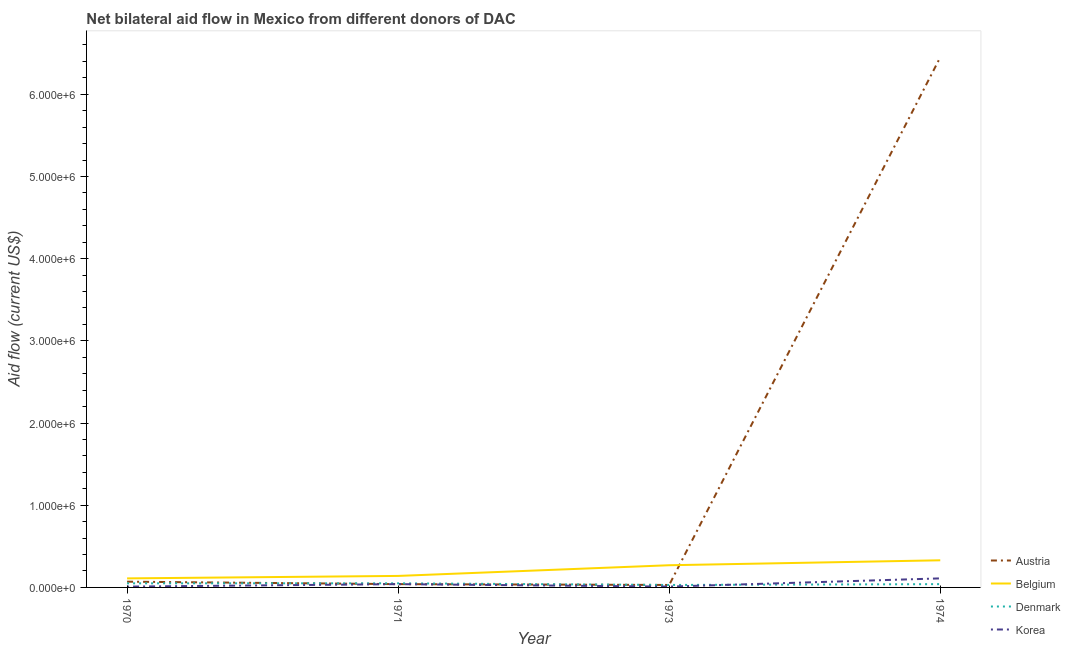How many different coloured lines are there?
Offer a terse response. 4. Is the number of lines equal to the number of legend labels?
Provide a short and direct response. Yes. What is the amount of aid given by korea in 1974?
Ensure brevity in your answer.  1.10e+05. Across all years, what is the maximum amount of aid given by austria?
Your response must be concise. 6.45e+06. Across all years, what is the minimum amount of aid given by belgium?
Your answer should be compact. 1.10e+05. What is the total amount of aid given by austria in the graph?
Your answer should be very brief. 6.59e+06. What is the difference between the amount of aid given by korea in 1971 and that in 1973?
Make the answer very short. 3.00e+04. What is the difference between the amount of aid given by belgium in 1971 and the amount of aid given by korea in 1973?
Your answer should be compact. 1.30e+05. What is the average amount of aid given by denmark per year?
Provide a succinct answer. 4.25e+04. In the year 1970, what is the difference between the amount of aid given by denmark and amount of aid given by belgium?
Your answer should be very brief. -6.00e+04. What is the ratio of the amount of aid given by austria in 1970 to that in 1974?
Ensure brevity in your answer.  0.01. Is the difference between the amount of aid given by austria in 1970 and 1974 greater than the difference between the amount of aid given by korea in 1970 and 1974?
Your answer should be very brief. No. What is the difference between the highest and the second highest amount of aid given by austria?
Keep it short and to the point. 6.38e+06. What is the difference between the highest and the lowest amount of aid given by denmark?
Give a very brief answer. 2.00e+04. Is the sum of the amount of aid given by belgium in 1970 and 1974 greater than the maximum amount of aid given by denmark across all years?
Offer a very short reply. Yes. Is it the case that in every year, the sum of the amount of aid given by austria and amount of aid given by belgium is greater than the amount of aid given by denmark?
Offer a very short reply. Yes. Does the amount of aid given by belgium monotonically increase over the years?
Make the answer very short. Yes. Is the amount of aid given by korea strictly greater than the amount of aid given by belgium over the years?
Offer a terse response. No. Is the amount of aid given by austria strictly less than the amount of aid given by denmark over the years?
Give a very brief answer. No. How many lines are there?
Provide a short and direct response. 4. How many years are there in the graph?
Ensure brevity in your answer.  4. Are the values on the major ticks of Y-axis written in scientific E-notation?
Ensure brevity in your answer.  Yes. Where does the legend appear in the graph?
Provide a short and direct response. Bottom right. How many legend labels are there?
Provide a succinct answer. 4. How are the legend labels stacked?
Offer a terse response. Vertical. What is the title of the graph?
Offer a very short reply. Net bilateral aid flow in Mexico from different donors of DAC. Does "Subsidies and Transfers" appear as one of the legend labels in the graph?
Offer a very short reply. No. What is the label or title of the X-axis?
Your answer should be very brief. Year. What is the label or title of the Y-axis?
Give a very brief answer. Aid flow (current US$). What is the Aid flow (current US$) of Denmark in 1970?
Your answer should be very brief. 5.00e+04. What is the Aid flow (current US$) of Austria in 1971?
Ensure brevity in your answer.  4.00e+04. What is the Aid flow (current US$) in Belgium in 1971?
Give a very brief answer. 1.40e+05. What is the Aid flow (current US$) of Denmark in 1971?
Make the answer very short. 5.00e+04. What is the Aid flow (current US$) of Austria in 1973?
Offer a terse response. 3.00e+04. What is the Aid flow (current US$) of Belgium in 1973?
Provide a short and direct response. 2.70e+05. What is the Aid flow (current US$) of Austria in 1974?
Offer a terse response. 6.45e+06. What is the Aid flow (current US$) of Korea in 1974?
Your answer should be very brief. 1.10e+05. Across all years, what is the maximum Aid flow (current US$) in Austria?
Give a very brief answer. 6.45e+06. Across all years, what is the maximum Aid flow (current US$) in Korea?
Offer a very short reply. 1.10e+05. Across all years, what is the minimum Aid flow (current US$) of Belgium?
Your answer should be compact. 1.10e+05. Across all years, what is the minimum Aid flow (current US$) in Denmark?
Your answer should be compact. 3.00e+04. Across all years, what is the minimum Aid flow (current US$) in Korea?
Your answer should be very brief. 10000. What is the total Aid flow (current US$) in Austria in the graph?
Your response must be concise. 6.59e+06. What is the total Aid flow (current US$) of Belgium in the graph?
Offer a very short reply. 8.50e+05. What is the total Aid flow (current US$) in Denmark in the graph?
Keep it short and to the point. 1.70e+05. What is the total Aid flow (current US$) of Korea in the graph?
Your answer should be very brief. 1.70e+05. What is the difference between the Aid flow (current US$) of Austria in 1970 and that in 1971?
Your response must be concise. 3.00e+04. What is the difference between the Aid flow (current US$) of Belgium in 1970 and that in 1971?
Give a very brief answer. -3.00e+04. What is the difference between the Aid flow (current US$) in Denmark in 1970 and that in 1971?
Provide a succinct answer. 0. What is the difference between the Aid flow (current US$) in Austria in 1970 and that in 1973?
Make the answer very short. 4.00e+04. What is the difference between the Aid flow (current US$) of Denmark in 1970 and that in 1973?
Provide a succinct answer. 2.00e+04. What is the difference between the Aid flow (current US$) in Austria in 1970 and that in 1974?
Give a very brief answer. -6.38e+06. What is the difference between the Aid flow (current US$) of Denmark in 1970 and that in 1974?
Your response must be concise. 10000. What is the difference between the Aid flow (current US$) of Korea in 1970 and that in 1974?
Provide a succinct answer. -1.00e+05. What is the difference between the Aid flow (current US$) in Denmark in 1971 and that in 1973?
Your answer should be compact. 2.00e+04. What is the difference between the Aid flow (current US$) in Austria in 1971 and that in 1974?
Keep it short and to the point. -6.41e+06. What is the difference between the Aid flow (current US$) of Denmark in 1971 and that in 1974?
Ensure brevity in your answer.  10000. What is the difference between the Aid flow (current US$) in Korea in 1971 and that in 1974?
Your response must be concise. -7.00e+04. What is the difference between the Aid flow (current US$) of Austria in 1973 and that in 1974?
Make the answer very short. -6.42e+06. What is the difference between the Aid flow (current US$) of Denmark in 1973 and that in 1974?
Give a very brief answer. -10000. What is the difference between the Aid flow (current US$) of Korea in 1973 and that in 1974?
Ensure brevity in your answer.  -1.00e+05. What is the difference between the Aid flow (current US$) of Belgium in 1970 and the Aid flow (current US$) of Korea in 1971?
Make the answer very short. 7.00e+04. What is the difference between the Aid flow (current US$) of Austria in 1970 and the Aid flow (current US$) of Belgium in 1973?
Give a very brief answer. -2.00e+05. What is the difference between the Aid flow (current US$) of Austria in 1970 and the Aid flow (current US$) of Denmark in 1973?
Your answer should be compact. 4.00e+04. What is the difference between the Aid flow (current US$) of Austria in 1970 and the Aid flow (current US$) of Korea in 1973?
Offer a very short reply. 6.00e+04. What is the difference between the Aid flow (current US$) of Belgium in 1970 and the Aid flow (current US$) of Denmark in 1973?
Your response must be concise. 8.00e+04. What is the difference between the Aid flow (current US$) in Belgium in 1970 and the Aid flow (current US$) in Korea in 1973?
Ensure brevity in your answer.  1.00e+05. What is the difference between the Aid flow (current US$) of Denmark in 1970 and the Aid flow (current US$) of Korea in 1973?
Provide a short and direct response. 4.00e+04. What is the difference between the Aid flow (current US$) of Belgium in 1970 and the Aid flow (current US$) of Denmark in 1974?
Give a very brief answer. 7.00e+04. What is the difference between the Aid flow (current US$) of Denmark in 1970 and the Aid flow (current US$) of Korea in 1974?
Offer a terse response. -6.00e+04. What is the difference between the Aid flow (current US$) in Austria in 1971 and the Aid flow (current US$) in Korea in 1973?
Provide a short and direct response. 3.00e+04. What is the difference between the Aid flow (current US$) in Belgium in 1971 and the Aid flow (current US$) in Denmark in 1973?
Give a very brief answer. 1.10e+05. What is the difference between the Aid flow (current US$) of Belgium in 1971 and the Aid flow (current US$) of Korea in 1973?
Keep it short and to the point. 1.30e+05. What is the difference between the Aid flow (current US$) of Austria in 1971 and the Aid flow (current US$) of Belgium in 1974?
Ensure brevity in your answer.  -2.90e+05. What is the difference between the Aid flow (current US$) of Austria in 1973 and the Aid flow (current US$) of Belgium in 1974?
Your response must be concise. -3.00e+05. What is the difference between the Aid flow (current US$) in Austria in 1973 and the Aid flow (current US$) in Denmark in 1974?
Give a very brief answer. -10000. What is the difference between the Aid flow (current US$) of Austria in 1973 and the Aid flow (current US$) of Korea in 1974?
Offer a terse response. -8.00e+04. What is the difference between the Aid flow (current US$) in Belgium in 1973 and the Aid flow (current US$) in Denmark in 1974?
Offer a very short reply. 2.30e+05. What is the difference between the Aid flow (current US$) in Belgium in 1973 and the Aid flow (current US$) in Korea in 1974?
Your response must be concise. 1.60e+05. What is the difference between the Aid flow (current US$) of Denmark in 1973 and the Aid flow (current US$) of Korea in 1974?
Your answer should be very brief. -8.00e+04. What is the average Aid flow (current US$) of Austria per year?
Provide a succinct answer. 1.65e+06. What is the average Aid flow (current US$) of Belgium per year?
Offer a very short reply. 2.12e+05. What is the average Aid flow (current US$) of Denmark per year?
Your answer should be very brief. 4.25e+04. What is the average Aid flow (current US$) of Korea per year?
Provide a short and direct response. 4.25e+04. In the year 1970, what is the difference between the Aid flow (current US$) in Austria and Aid flow (current US$) in Belgium?
Give a very brief answer. -4.00e+04. In the year 1970, what is the difference between the Aid flow (current US$) in Austria and Aid flow (current US$) in Denmark?
Keep it short and to the point. 2.00e+04. In the year 1970, what is the difference between the Aid flow (current US$) in Denmark and Aid flow (current US$) in Korea?
Your answer should be very brief. 4.00e+04. In the year 1971, what is the difference between the Aid flow (current US$) in Austria and Aid flow (current US$) in Korea?
Make the answer very short. 0. In the year 1973, what is the difference between the Aid flow (current US$) in Austria and Aid flow (current US$) in Korea?
Your response must be concise. 2.00e+04. In the year 1973, what is the difference between the Aid flow (current US$) in Belgium and Aid flow (current US$) in Korea?
Provide a short and direct response. 2.60e+05. In the year 1974, what is the difference between the Aid flow (current US$) of Austria and Aid flow (current US$) of Belgium?
Make the answer very short. 6.12e+06. In the year 1974, what is the difference between the Aid flow (current US$) of Austria and Aid flow (current US$) of Denmark?
Your answer should be very brief. 6.41e+06. In the year 1974, what is the difference between the Aid flow (current US$) in Austria and Aid flow (current US$) in Korea?
Make the answer very short. 6.34e+06. In the year 1974, what is the difference between the Aid flow (current US$) in Belgium and Aid flow (current US$) in Korea?
Provide a succinct answer. 2.20e+05. What is the ratio of the Aid flow (current US$) of Belgium in 1970 to that in 1971?
Provide a succinct answer. 0.79. What is the ratio of the Aid flow (current US$) in Denmark in 1970 to that in 1971?
Provide a short and direct response. 1. What is the ratio of the Aid flow (current US$) of Korea in 1970 to that in 1971?
Ensure brevity in your answer.  0.25. What is the ratio of the Aid flow (current US$) of Austria in 1970 to that in 1973?
Keep it short and to the point. 2.33. What is the ratio of the Aid flow (current US$) of Belgium in 1970 to that in 1973?
Give a very brief answer. 0.41. What is the ratio of the Aid flow (current US$) in Denmark in 1970 to that in 1973?
Offer a very short reply. 1.67. What is the ratio of the Aid flow (current US$) of Korea in 1970 to that in 1973?
Provide a short and direct response. 1. What is the ratio of the Aid flow (current US$) of Austria in 1970 to that in 1974?
Offer a terse response. 0.01. What is the ratio of the Aid flow (current US$) in Korea in 1970 to that in 1974?
Your answer should be very brief. 0.09. What is the ratio of the Aid flow (current US$) of Austria in 1971 to that in 1973?
Provide a short and direct response. 1.33. What is the ratio of the Aid flow (current US$) of Belgium in 1971 to that in 1973?
Offer a terse response. 0.52. What is the ratio of the Aid flow (current US$) in Denmark in 1971 to that in 1973?
Provide a short and direct response. 1.67. What is the ratio of the Aid flow (current US$) in Austria in 1971 to that in 1974?
Ensure brevity in your answer.  0.01. What is the ratio of the Aid flow (current US$) in Belgium in 1971 to that in 1974?
Your answer should be compact. 0.42. What is the ratio of the Aid flow (current US$) in Korea in 1971 to that in 1974?
Keep it short and to the point. 0.36. What is the ratio of the Aid flow (current US$) of Austria in 1973 to that in 1974?
Provide a short and direct response. 0. What is the ratio of the Aid flow (current US$) of Belgium in 1973 to that in 1974?
Your response must be concise. 0.82. What is the ratio of the Aid flow (current US$) of Korea in 1973 to that in 1974?
Make the answer very short. 0.09. What is the difference between the highest and the second highest Aid flow (current US$) of Austria?
Keep it short and to the point. 6.38e+06. What is the difference between the highest and the second highest Aid flow (current US$) in Belgium?
Ensure brevity in your answer.  6.00e+04. What is the difference between the highest and the lowest Aid flow (current US$) of Austria?
Keep it short and to the point. 6.42e+06. What is the difference between the highest and the lowest Aid flow (current US$) in Belgium?
Your answer should be very brief. 2.20e+05. What is the difference between the highest and the lowest Aid flow (current US$) of Denmark?
Your answer should be very brief. 2.00e+04. 